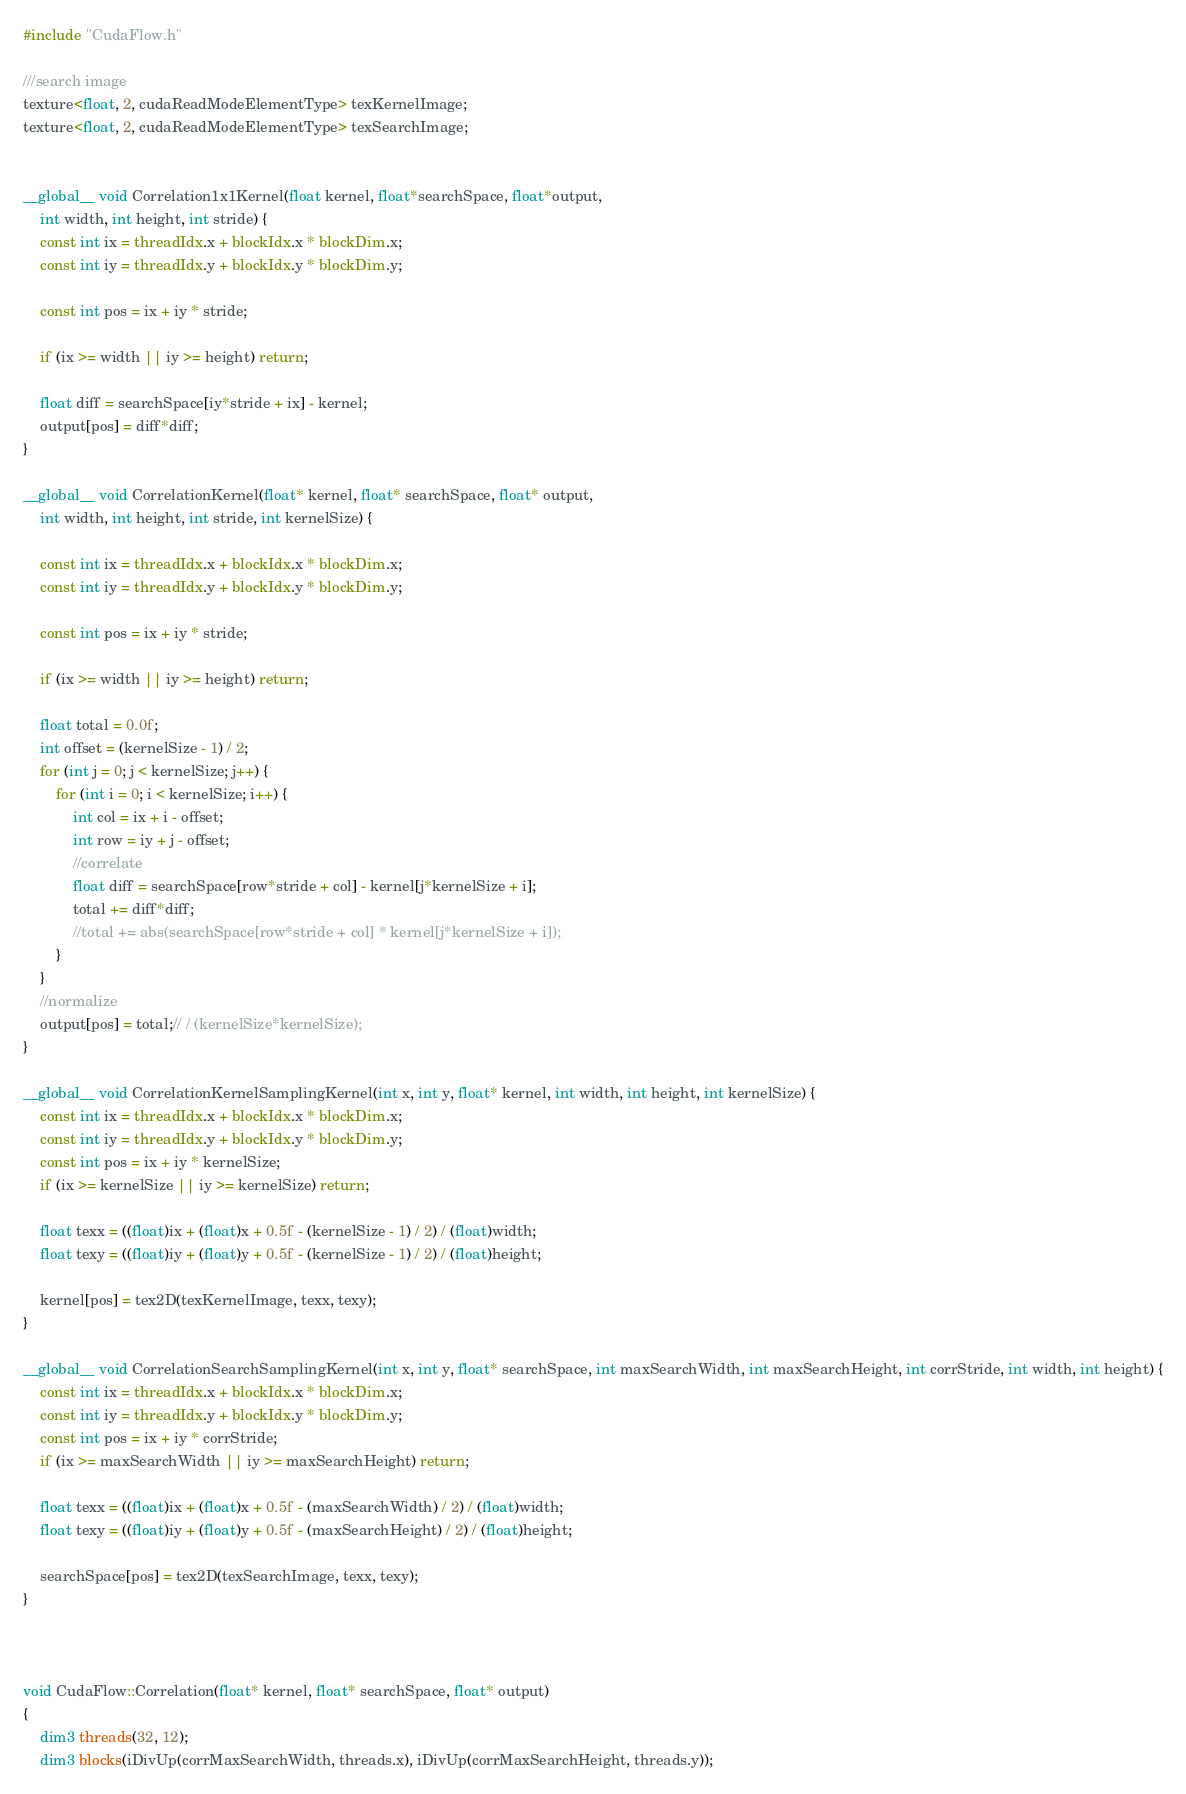<code> <loc_0><loc_0><loc_500><loc_500><_Cuda_>#include "CudaFlow.h"

///search image
texture<float, 2, cudaReadModeElementType> texKernelImage;
texture<float, 2, cudaReadModeElementType> texSearchImage;


__global__ void Correlation1x1Kernel(float kernel, float*searchSpace, float*output,
	int width, int height, int stride) {
	const int ix = threadIdx.x + blockIdx.x * blockDim.x;
	const int iy = threadIdx.y + blockIdx.y * blockDim.y;

	const int pos = ix + iy * stride;

	if (ix >= width || iy >= height) return;

	float diff = searchSpace[iy*stride + ix] - kernel;
	output[pos] = diff*diff;
}

__global__ void CorrelationKernel(float* kernel, float* searchSpace, float* output,
	int width, int height, int stride, int kernelSize) {

	const int ix = threadIdx.x + blockIdx.x * blockDim.x;
	const int iy = threadIdx.y + blockIdx.y * blockDim.y;

	const int pos = ix + iy * stride;

	if (ix >= width || iy >= height) return;

	float total = 0.0f;
	int offset = (kernelSize - 1) / 2;
	for (int j = 0; j < kernelSize; j++) {
		for (int i = 0; i < kernelSize; i++) {
			int col = ix + i - offset;
			int row = iy + j - offset;
			//correlate
			float diff = searchSpace[row*stride + col] - kernel[j*kernelSize + i];
			total += diff*diff;
			//total += abs(searchSpace[row*stride + col] * kernel[j*kernelSize + i]);
		}
	}
	//normalize
	output[pos] = total;// / (kernelSize*kernelSize);
}

__global__ void CorrelationKernelSamplingKernel(int x, int y, float* kernel, int width, int height, int kernelSize) {
	const int ix = threadIdx.x + blockIdx.x * blockDim.x;
	const int iy = threadIdx.y + blockIdx.y * blockDim.y;
	const int pos = ix + iy * kernelSize;
	if (ix >= kernelSize || iy >= kernelSize) return;

	float texx = ((float)ix + (float)x + 0.5f - (kernelSize - 1) / 2) / (float)width;
	float texy = ((float)iy + (float)y + 0.5f - (kernelSize - 1) / 2) / (float)height;

	kernel[pos] = tex2D(texKernelImage, texx, texy);
}

__global__ void CorrelationSearchSamplingKernel(int x, int y, float* searchSpace, int maxSearchWidth, int maxSearchHeight, int corrStride, int width, int height) {
	const int ix = threadIdx.x + blockIdx.x * blockDim.x;
	const int iy = threadIdx.y + blockIdx.y * blockDim.y;
	const int pos = ix + iy * corrStride;
	if (ix >= maxSearchWidth || iy >= maxSearchHeight) return;

	float texx = ((float)ix + (float)x + 0.5f - (maxSearchWidth) / 2) / (float)width;
	float texy = ((float)iy + (float)y + 0.5f - (maxSearchHeight) / 2) / (float)height;

	searchSpace[pos] = tex2D(texSearchImage, texx, texy);
}



void CudaFlow::Correlation(float* kernel, float* searchSpace, float* output)
{
	dim3 threads(32, 12);
	dim3 blocks(iDivUp(corrMaxSearchWidth, threads.x), iDivUp(corrMaxSearchHeight, threads.y));
</code> 